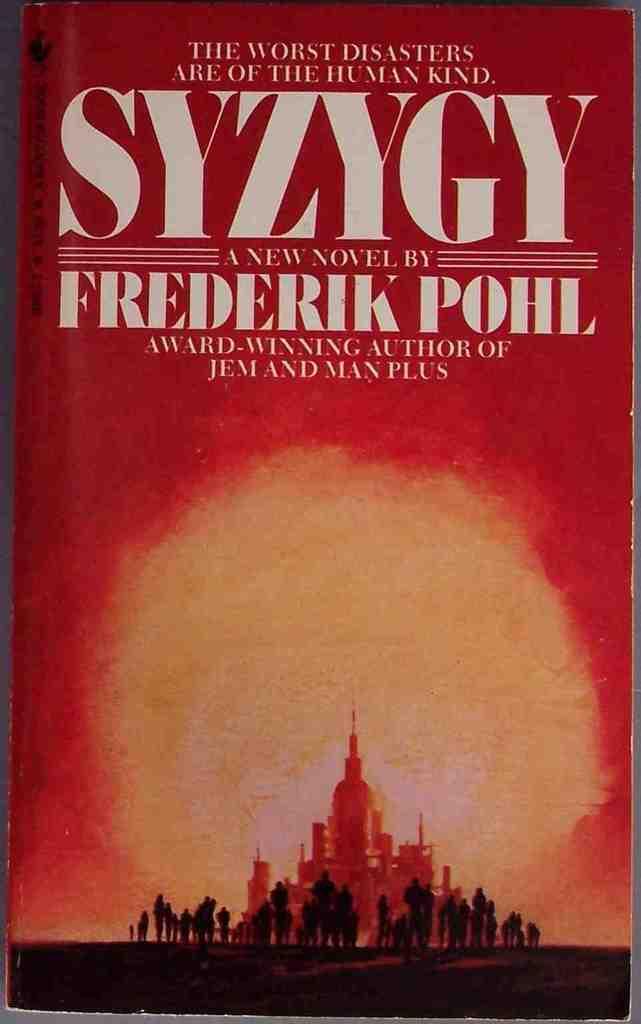What is the name is this book?
Provide a succinct answer. Syzygy. Who is the author of this book?
Provide a succinct answer. Frederik pohl. 